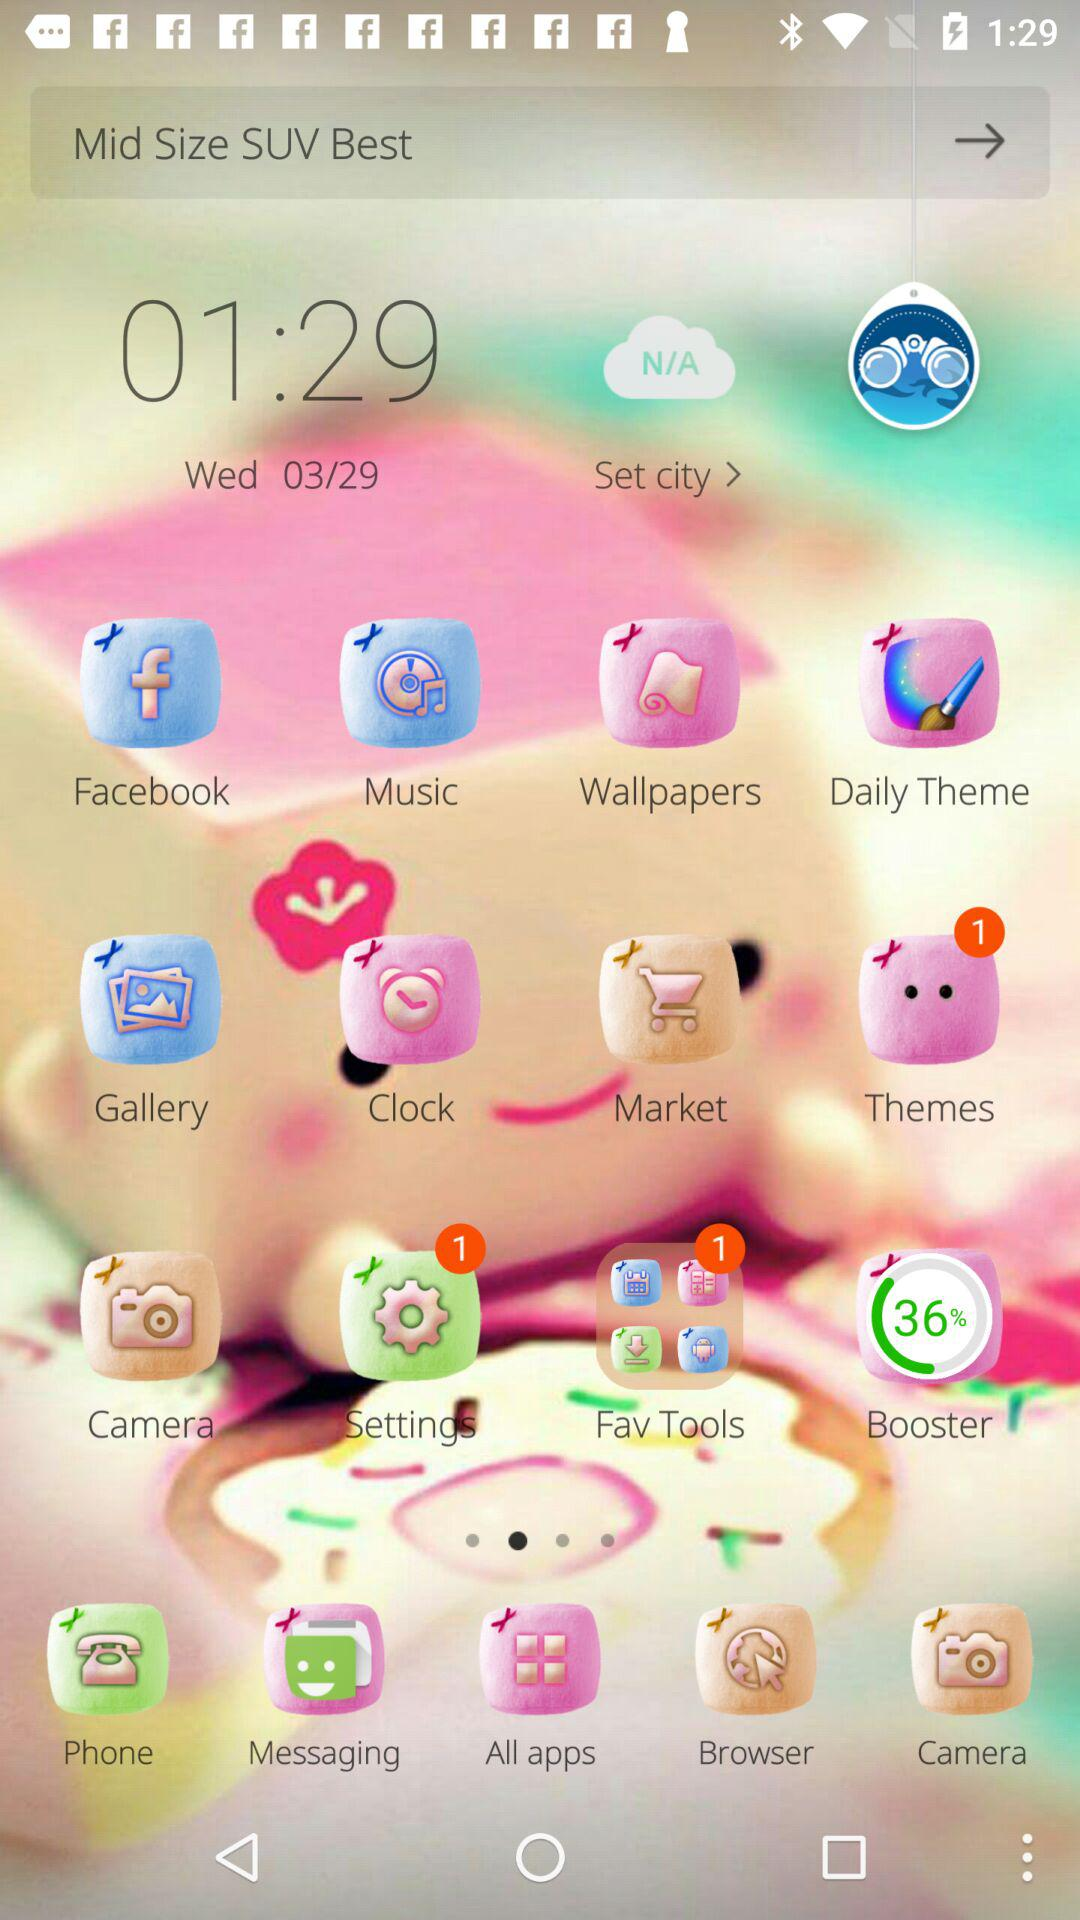How many notifications are unread in the "Settings"? The unread notification is 1. 